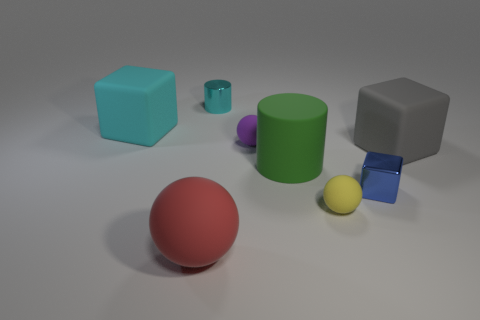Subtract all red spheres. How many spheres are left? 2 Add 2 big green matte cylinders. How many objects exist? 10 Subtract all blue blocks. How many blocks are left? 2 Subtract all cylinders. How many objects are left? 6 Subtract 2 blocks. How many blocks are left? 1 Add 6 small yellow objects. How many small yellow objects are left? 7 Add 5 big yellow cubes. How many big yellow cubes exist? 5 Subtract 0 blue cylinders. How many objects are left? 8 Subtract all yellow balls. Subtract all red blocks. How many balls are left? 2 Subtract all red things. Subtract all small cubes. How many objects are left? 6 